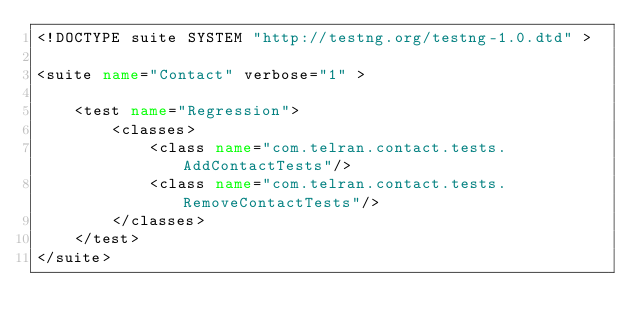<code> <loc_0><loc_0><loc_500><loc_500><_XML_><!DOCTYPE suite SYSTEM "http://testng.org/testng-1.0.dtd" >

<suite name="Contact" verbose="1" >

    <test name="Regression">
        <classes>
            <class name="com.telran.contact.tests.AddContactTests"/>
            <class name="com.telran.contact.tests.RemoveContactTests"/>
        </classes>
    </test>
</suite></code> 